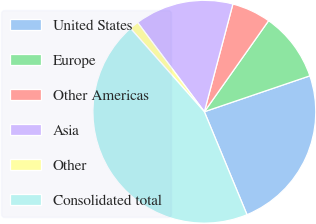Convert chart. <chart><loc_0><loc_0><loc_500><loc_500><pie_chart><fcel>United States<fcel>Europe<fcel>Other Americas<fcel>Asia<fcel>Other<fcel>Consolidated total<nl><fcel>23.97%<fcel>10.0%<fcel>5.66%<fcel>14.34%<fcel>1.32%<fcel>44.72%<nl></chart> 